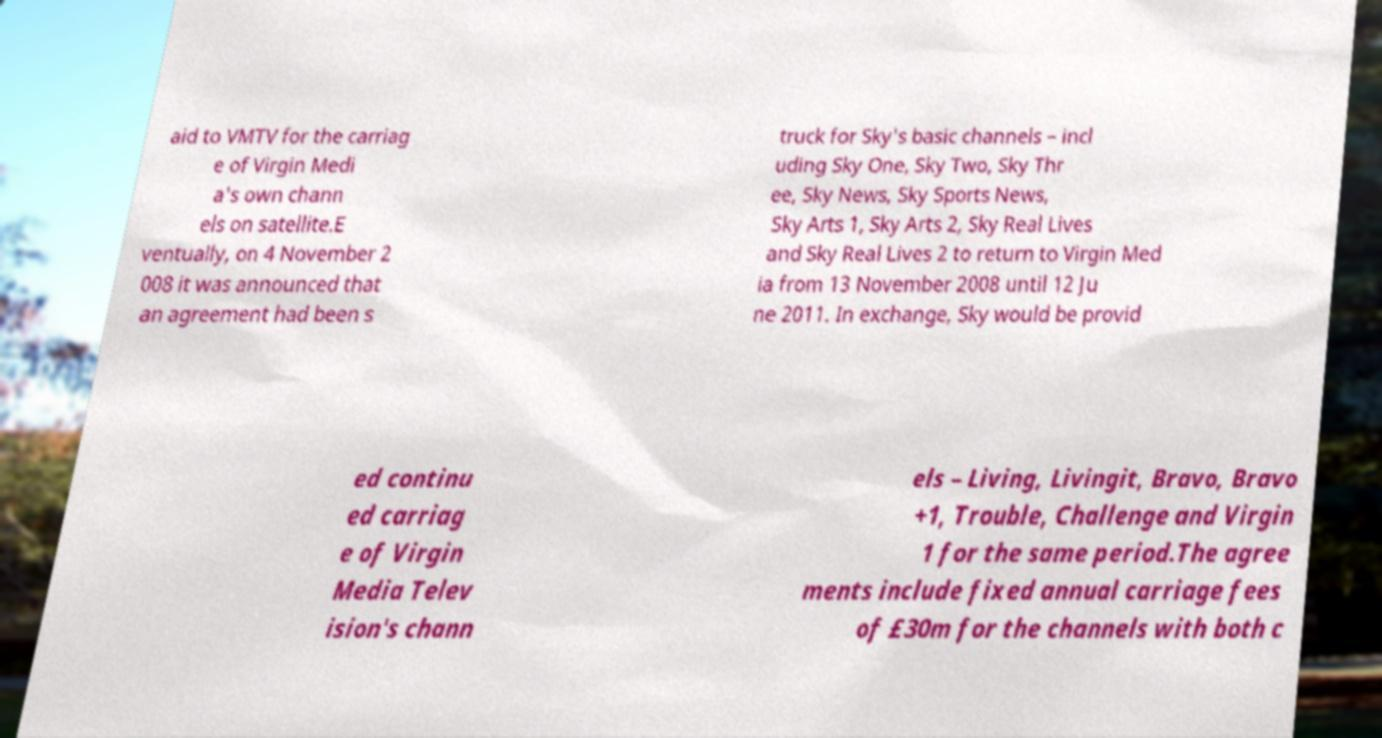Please read and relay the text visible in this image. What does it say? aid to VMTV for the carriag e of Virgin Medi a's own chann els on satellite.E ventually, on 4 November 2 008 it was announced that an agreement had been s truck for Sky's basic channels – incl uding Sky One, Sky Two, Sky Thr ee, Sky News, Sky Sports News, Sky Arts 1, Sky Arts 2, Sky Real Lives and Sky Real Lives 2 to return to Virgin Med ia from 13 November 2008 until 12 Ju ne 2011. In exchange, Sky would be provid ed continu ed carriag e of Virgin Media Telev ision's chann els – Living, Livingit, Bravo, Bravo +1, Trouble, Challenge and Virgin 1 for the same period.The agree ments include fixed annual carriage fees of £30m for the channels with both c 